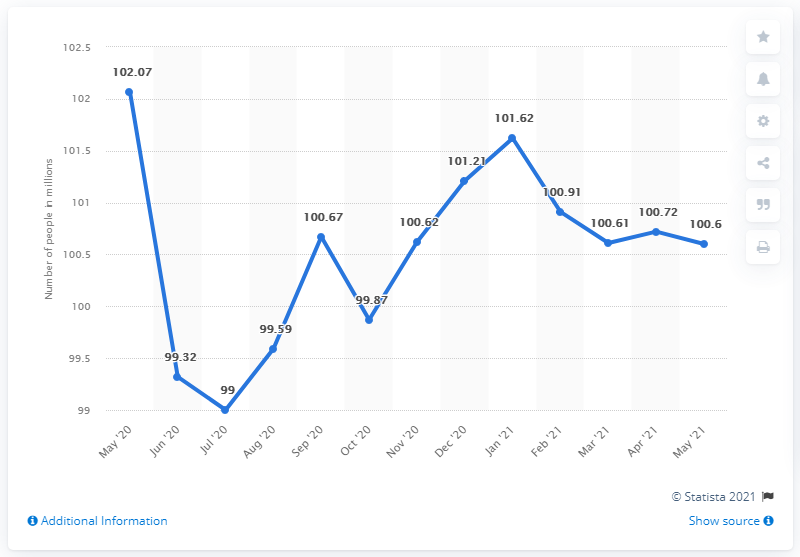Highlight a few significant elements in this photo. In May 2021, there were 100.6 people in the inactive labor force. 